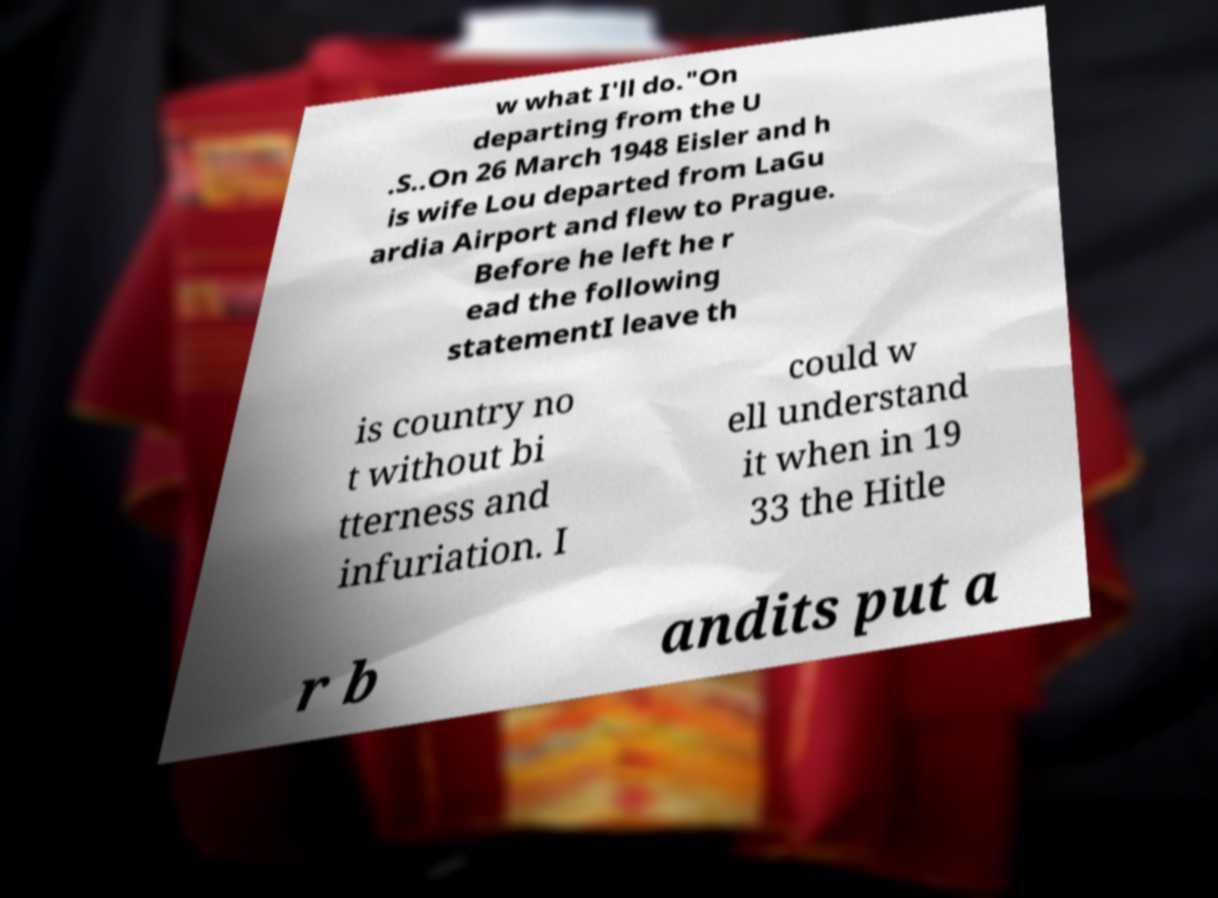Please identify and transcribe the text found in this image. w what I'll do."On departing from the U .S..On 26 March 1948 Eisler and h is wife Lou departed from LaGu ardia Airport and flew to Prague. Before he left he r ead the following statementI leave th is country no t without bi tterness and infuriation. I could w ell understand it when in 19 33 the Hitle r b andits put a 